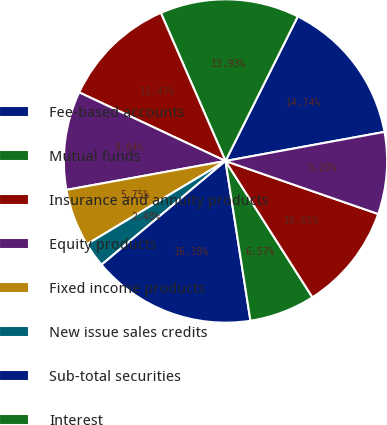Convert chart to OTSL. <chart><loc_0><loc_0><loc_500><loc_500><pie_chart><fcel>Fee-based accounts<fcel>Mutual funds<fcel>Insurance and annuity products<fcel>Equity products<fcel>Fixed income products<fcel>New issue sales credits<fcel>Sub-total securities<fcel>Interest<fcel>Mutual fund and annuity<fcel>RJBDP fees<nl><fcel>14.74%<fcel>13.93%<fcel>11.47%<fcel>9.84%<fcel>5.75%<fcel>2.48%<fcel>16.38%<fcel>6.57%<fcel>10.65%<fcel>8.2%<nl></chart> 